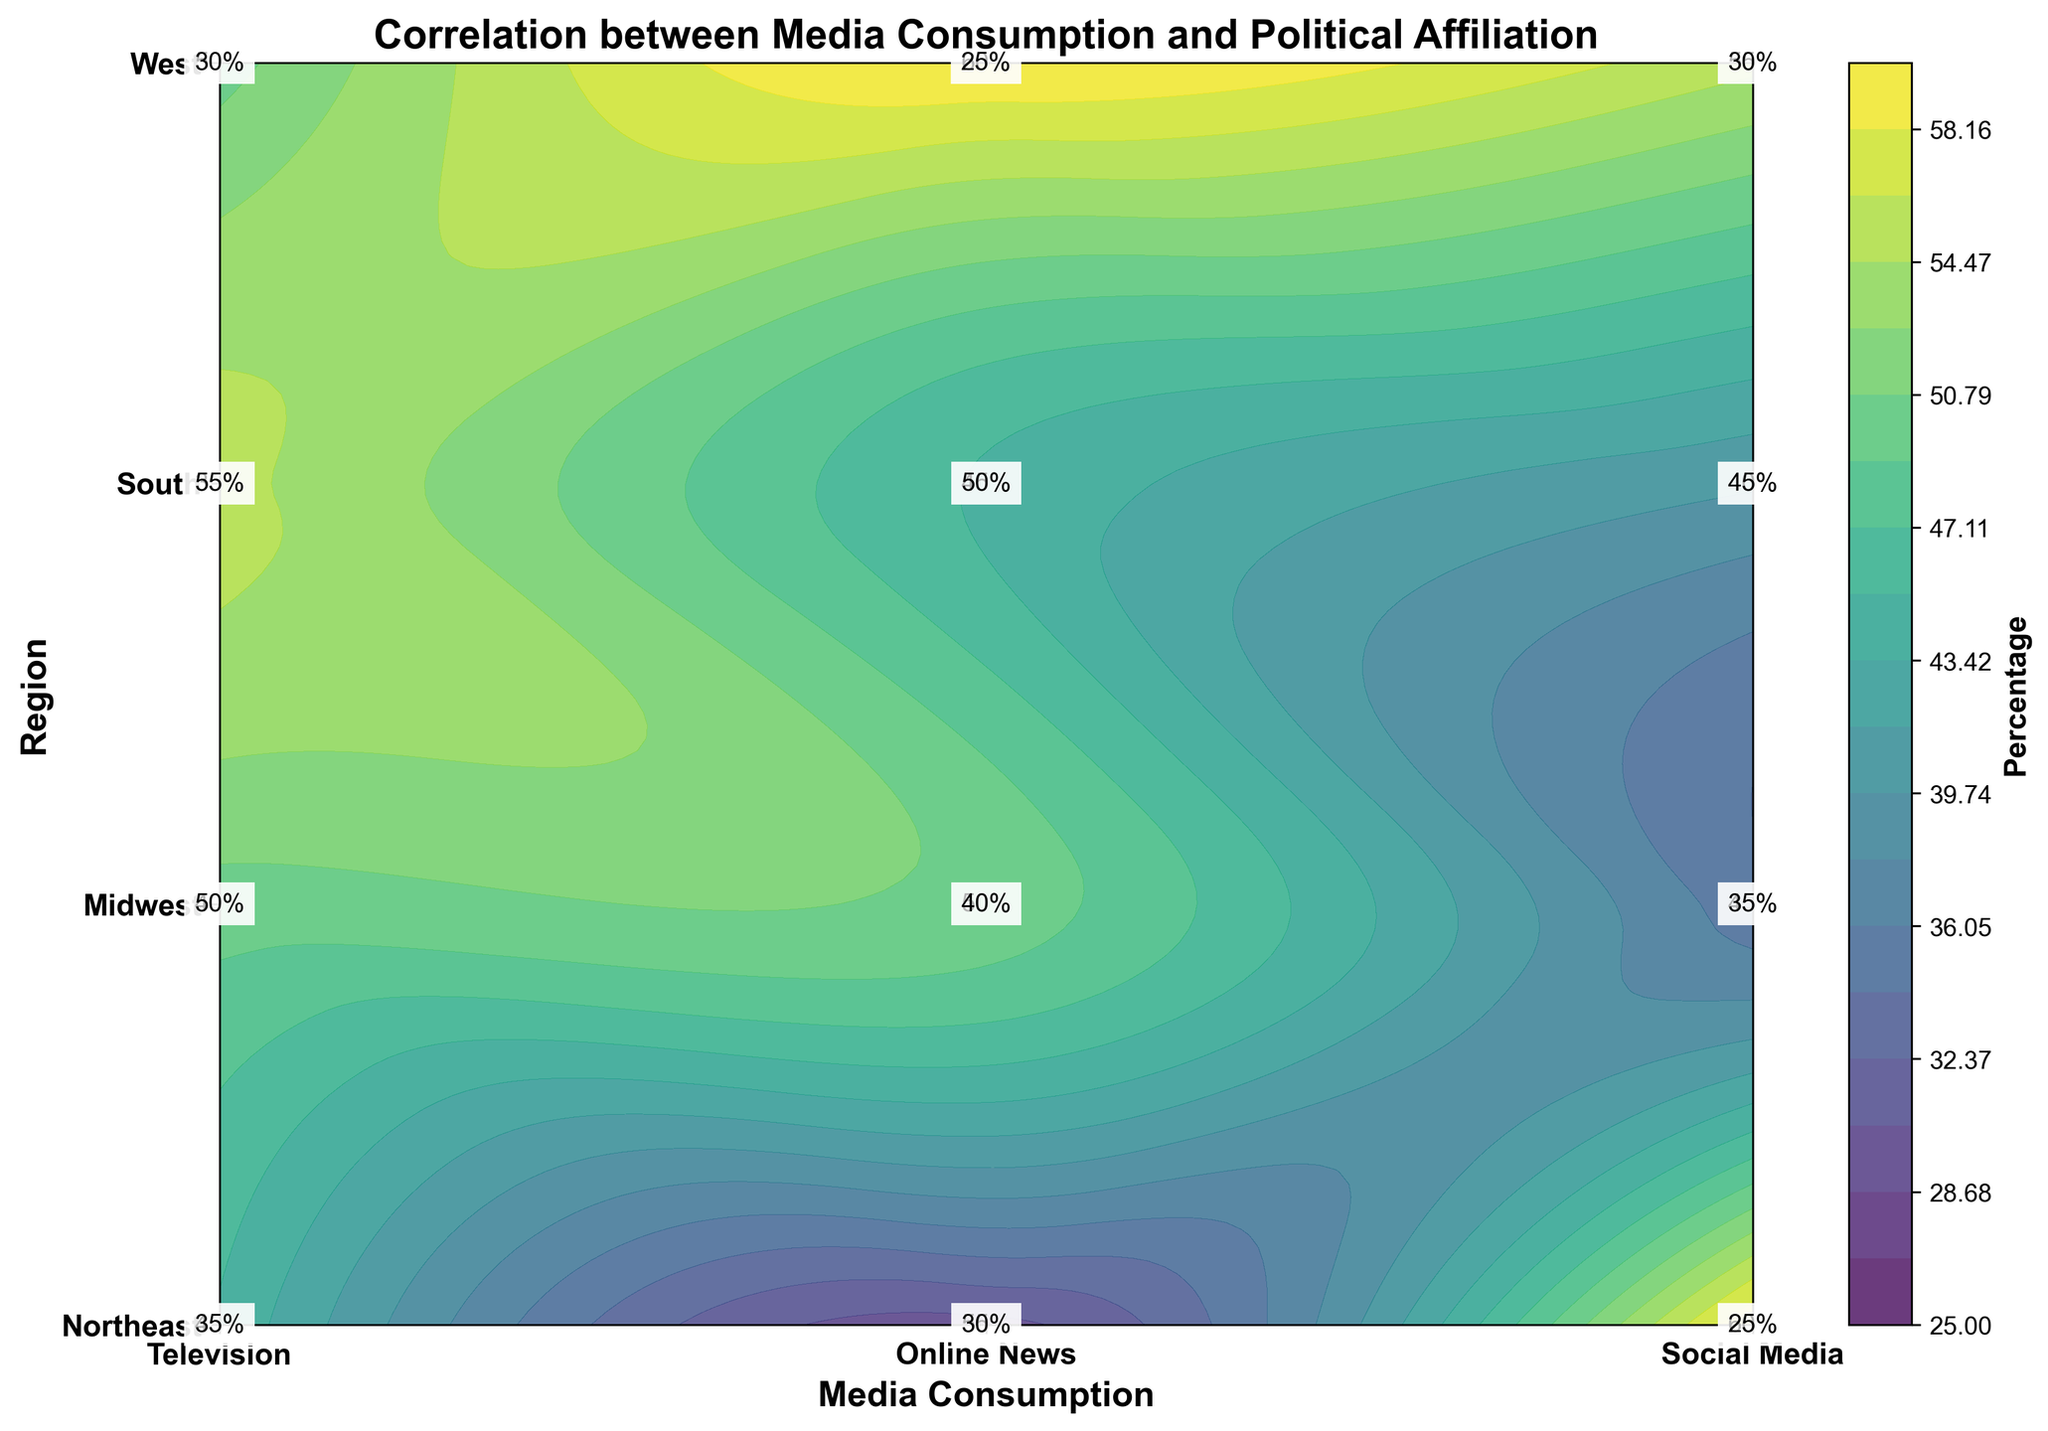What is the title of the figure? The title of the figure is located at the top center and it summarizes the main topic of the visual.
Answer: Correlation between Media Consumption and Political Affiliation Which media consumption type is most associated with the Democratic political affiliation in the West region? By looking at the color intensity in the contoured regions, we can infer that Online News has the highest percentage for Democratic affiliation in the West.
Answer: Online News Which media consumption type in the Midwest shows the highest affiliation with the Republican party? The contour levels along with the annotations suggest that Television has the highest percentage of Republican affiliation in the Midwest.
Answer: Television How does the media consumption habit for Social Media compare between the Northeast and the South regions for the Democratic party? By comparing the contour shades and the percentage annotations, it is evident that the Northeast (60%) has a higher Democratic affiliation with Social Media than the South (40%).
Answer: Northeast has higher What geographical region shows a higher Democratic affiliation with Online News, the Northeast or the Midwest? Observing the annotations and contour intensities of the respective regions, Northeast shows a 55% Democratic while Midwest shows 50%.
Answer: Northeast What is the highest percentage represented in the contour plot? By analyzing the highest contour level and percentage annotations, the maximum percentage is 60%, found under Democratic affiliation in Online News in the West and Social Media in the Northeast.
Answer: 60% Compare the percentage affiliation with Republican in the South between Television and Social Media. Looking at the annotations in the contour plot, Television in the South shows a 55% Republican affiliation while Social Media shows 45%.
Answer: Television is higher What is the affiliation trend for Democratic voters between Television and Online News in the Midwest? Referring to the percentage annotations, Television has a 40% Democratic affiliation while Online News has 50% in the Midwest.
Answer: Online News is higher Identify the region and media type with the lowest Republican affiliation. By checking the lowest percentage and corresponding annotations, Social Media in the Northeast shows the lowest Republican affiliation at 25%.
Answer: Social Media in Northeast In which region and media consumption type combination does the Democratic political affiliation percentage equal the Republican political affiliation percentage? By examining the percentages for both affiliations across all combinations, no such equal percentage combination is present in the provided data.
Answer: None 